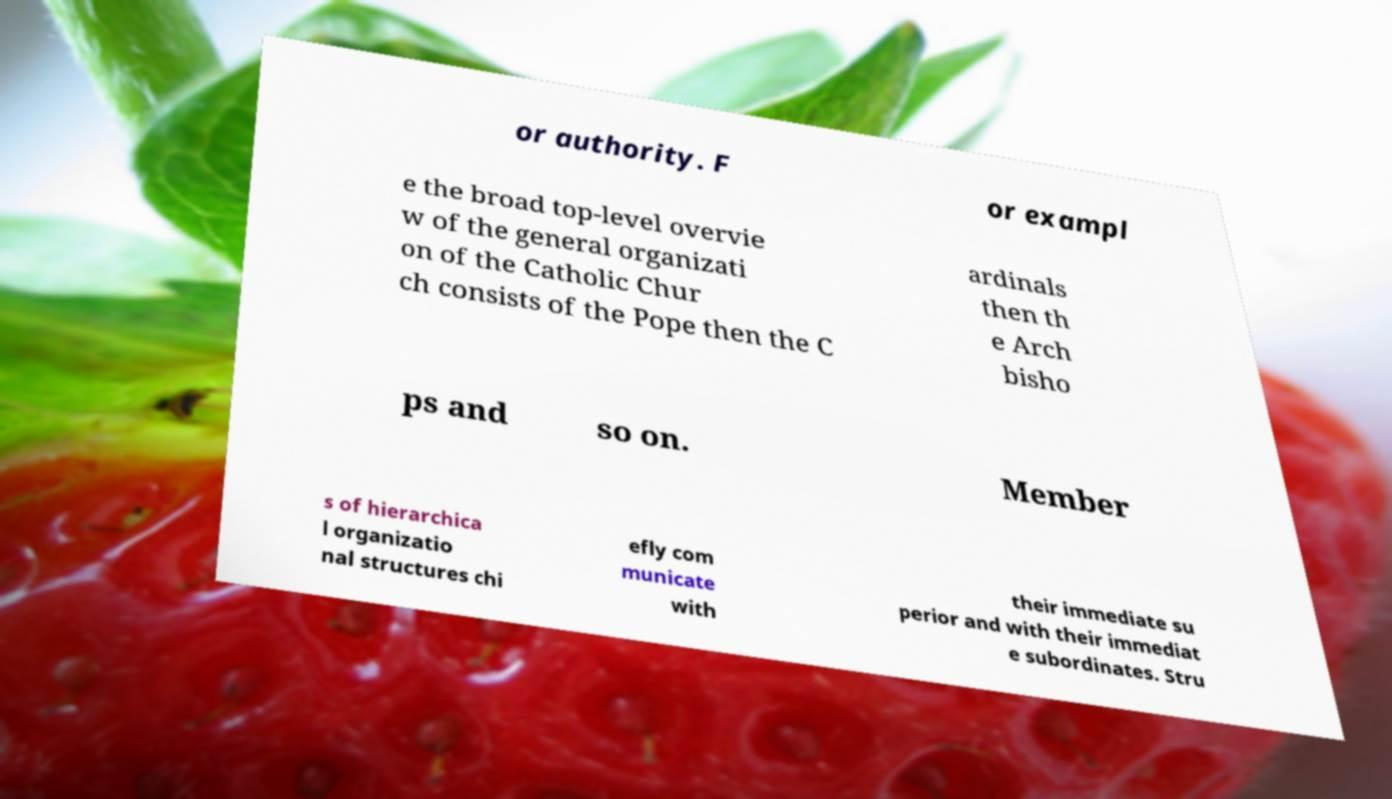What messages or text are displayed in this image? I need them in a readable, typed format. or authority. F or exampl e the broad top-level overvie w of the general organizati on of the Catholic Chur ch consists of the Pope then the C ardinals then th e Arch bisho ps and so on. Member s of hierarchica l organizatio nal structures chi efly com municate with their immediate su perior and with their immediat e subordinates. Stru 